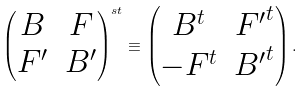<formula> <loc_0><loc_0><loc_500><loc_500>\begin{pmatrix} B & F \\ F ^ { \prime } & B ^ { \prime } \end{pmatrix} ^ { s t } \equiv \begin{pmatrix} B ^ { t } & { F ^ { \prime } } ^ { t } \\ - { F } ^ { t } & { B ^ { \prime } } ^ { t } \end{pmatrix} .</formula> 